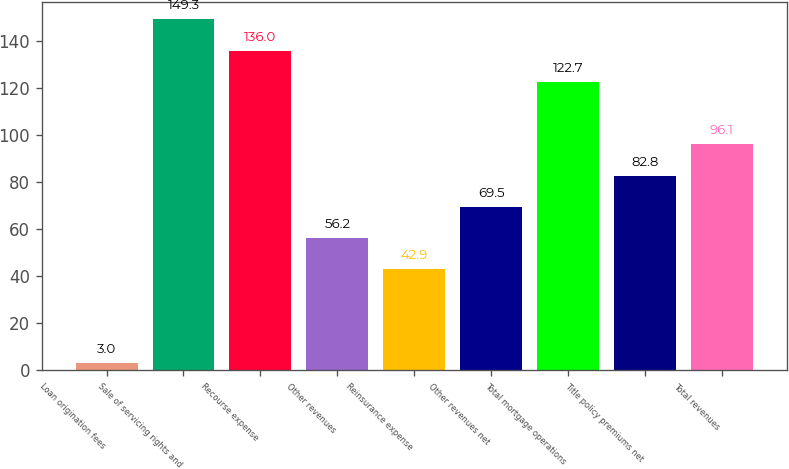<chart> <loc_0><loc_0><loc_500><loc_500><bar_chart><fcel>Loan origination fees<fcel>Sale of servicing rights and<fcel>Recourse expense<fcel>Other revenues<fcel>Reinsurance expense<fcel>Other revenues net<fcel>Total mortgage operations<fcel>Title policy premiums net<fcel>Total revenues<nl><fcel>3<fcel>149.3<fcel>136<fcel>56.2<fcel>42.9<fcel>69.5<fcel>122.7<fcel>82.8<fcel>96.1<nl></chart> 